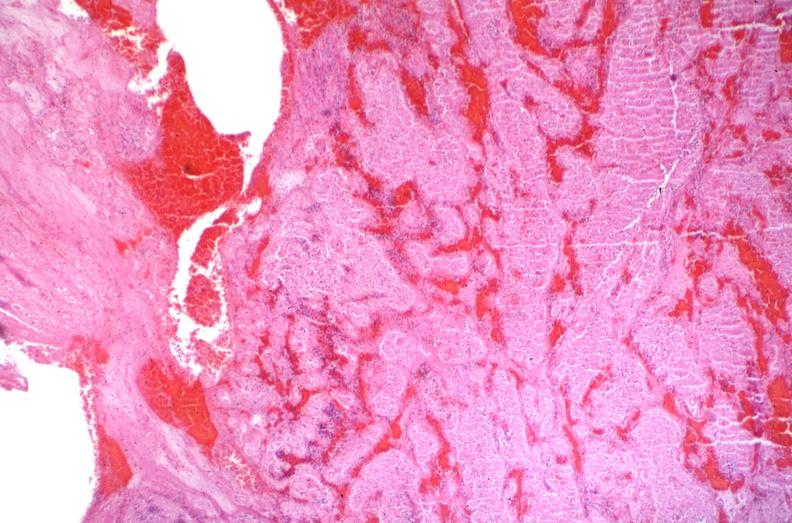s vasculature present?
Answer the question using a single word or phrase. Yes 